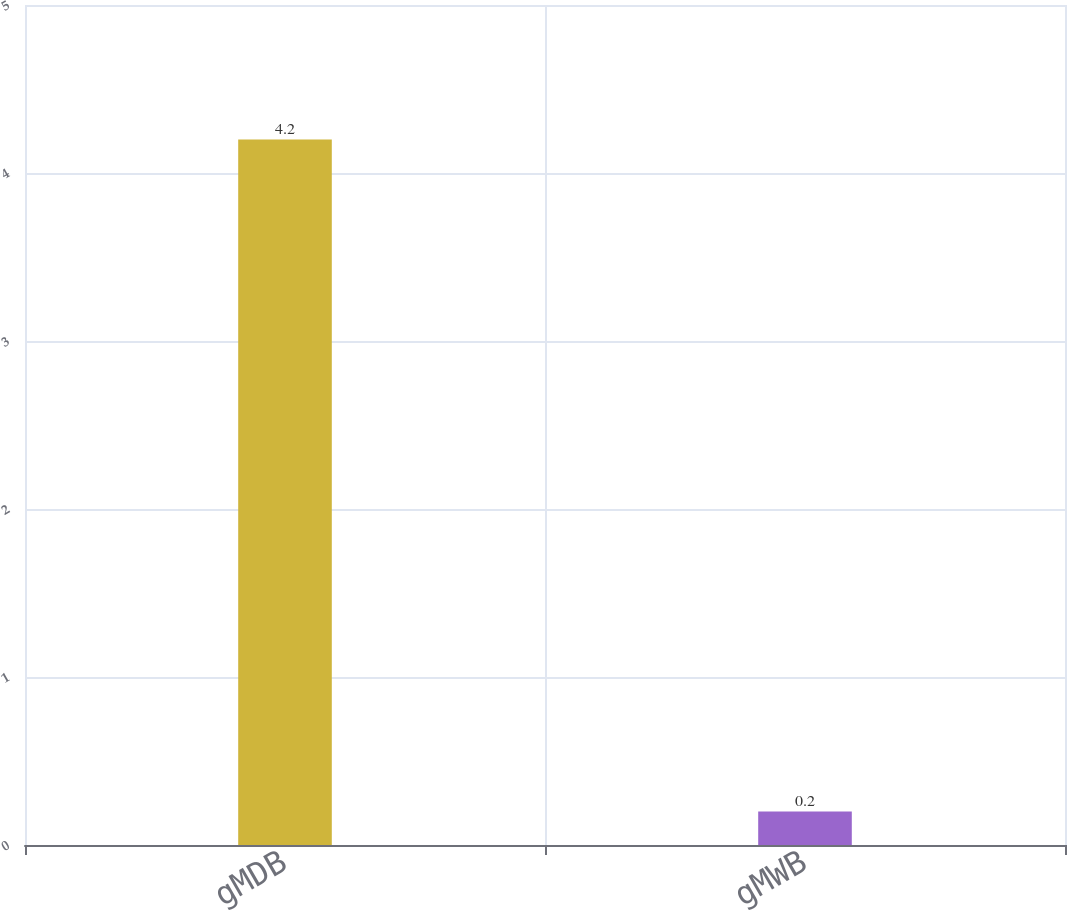<chart> <loc_0><loc_0><loc_500><loc_500><bar_chart><fcel>gMDB<fcel>gMWB<nl><fcel>4.2<fcel>0.2<nl></chart> 